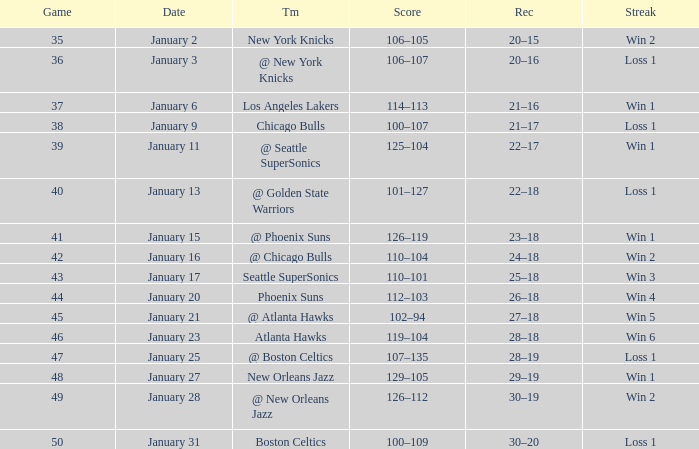What is the Team in Game 41? @ Phoenix Suns. 